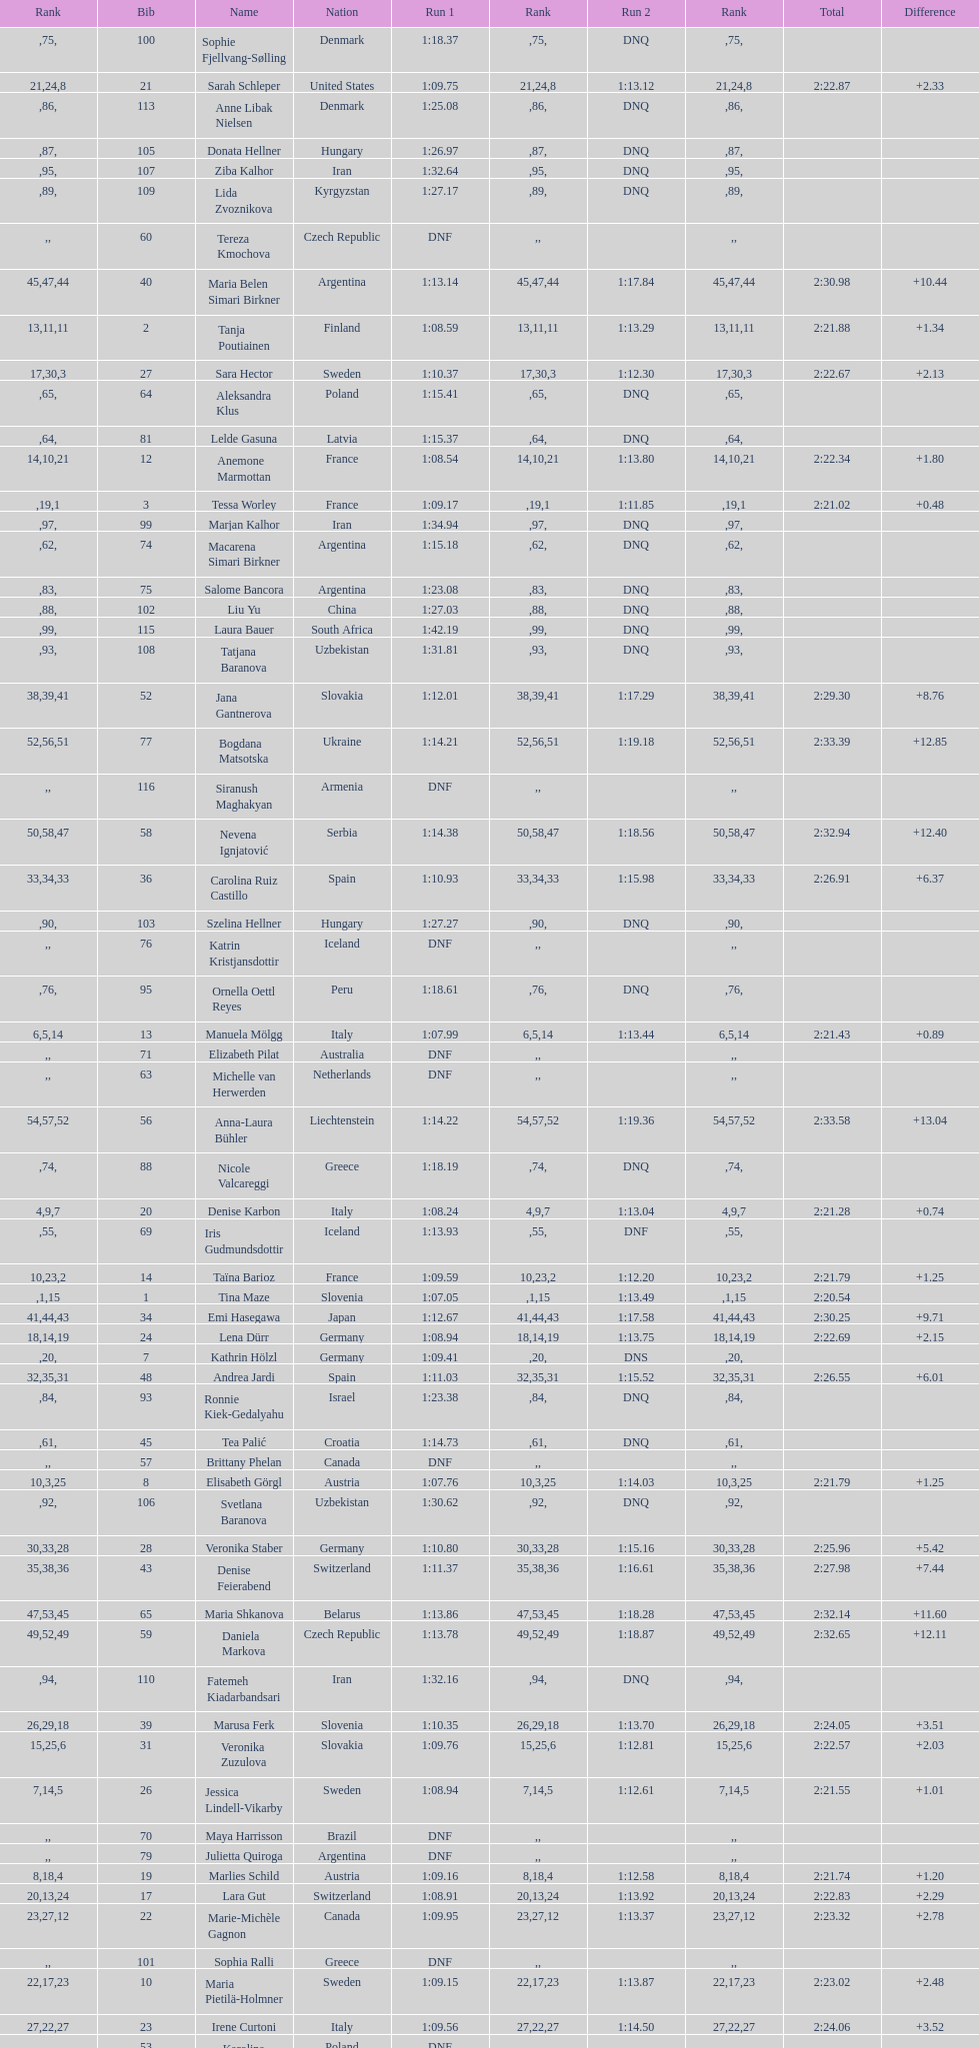How many names are there in total? 116. 